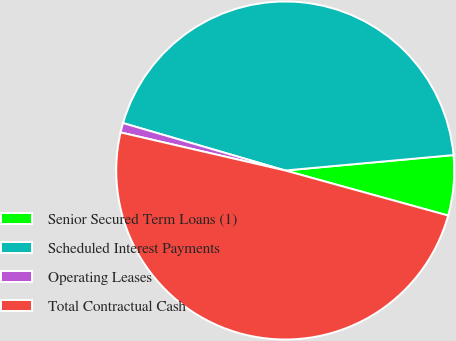Convert chart to OTSL. <chart><loc_0><loc_0><loc_500><loc_500><pie_chart><fcel>Senior Secured Term Loans (1)<fcel>Scheduled Interest Payments<fcel>Operating Leases<fcel>Total Contractual Cash<nl><fcel>5.75%<fcel>44.02%<fcel>0.91%<fcel>49.33%<nl></chart> 